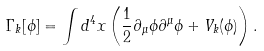Convert formula to latex. <formula><loc_0><loc_0><loc_500><loc_500>\Gamma _ { k } [ \phi ] = \int d ^ { 4 } x \left ( \frac { 1 } { 2 } \partial _ { \mu } \phi \partial ^ { \mu } \phi + V _ { k } ( \phi ) \right ) .</formula> 